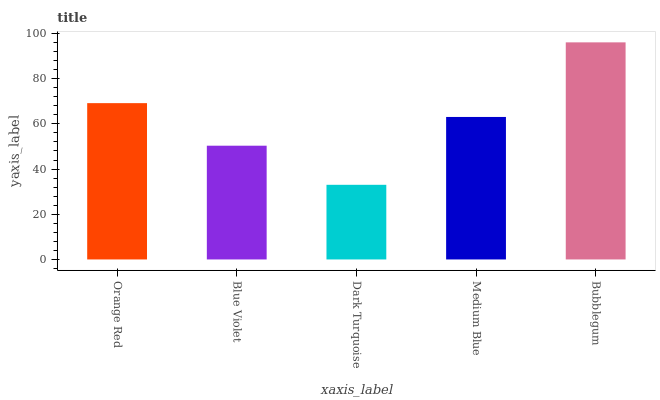Is Dark Turquoise the minimum?
Answer yes or no. Yes. Is Bubblegum the maximum?
Answer yes or no. Yes. Is Blue Violet the minimum?
Answer yes or no. No. Is Blue Violet the maximum?
Answer yes or no. No. Is Orange Red greater than Blue Violet?
Answer yes or no. Yes. Is Blue Violet less than Orange Red?
Answer yes or no. Yes. Is Blue Violet greater than Orange Red?
Answer yes or no. No. Is Orange Red less than Blue Violet?
Answer yes or no. No. Is Medium Blue the high median?
Answer yes or no. Yes. Is Medium Blue the low median?
Answer yes or no. Yes. Is Orange Red the high median?
Answer yes or no. No. Is Blue Violet the low median?
Answer yes or no. No. 